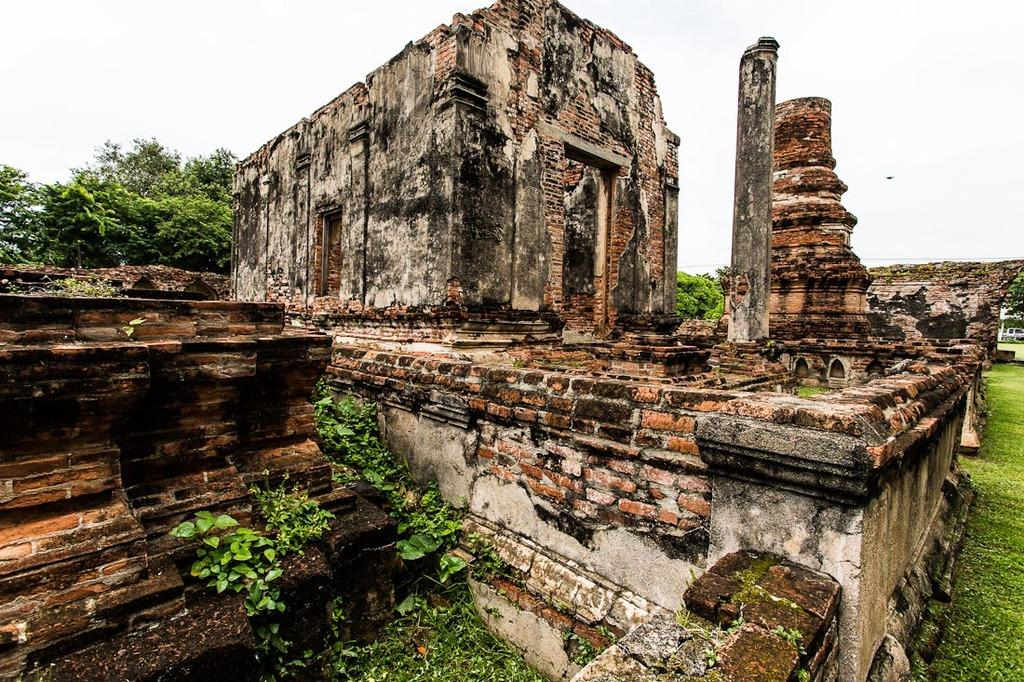What is the main subject of the image? The main subject of the image is a collapsed building. What type of vegetation can be seen in the image? There is grass visible in the image. What architectural features are present in the image? There are walls in the image. What else can be seen in the background of the image? There are trees and the sky visible in the background of the image. Can you see the brothers walking along the sea in the image? There is no sea or brothers present in the image; it features a collapsed building, grass, walls, trees, and the sky. 